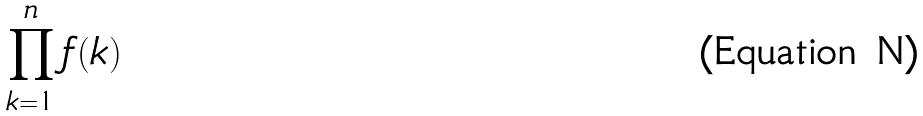<formula> <loc_0><loc_0><loc_500><loc_500>\prod _ { k = 1 } ^ { n } f ( k )</formula> 